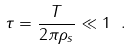Convert formula to latex. <formula><loc_0><loc_0><loc_500><loc_500>\tau = \frac { T } { 2 \pi \rho _ { s } } \ll 1 \ .</formula> 